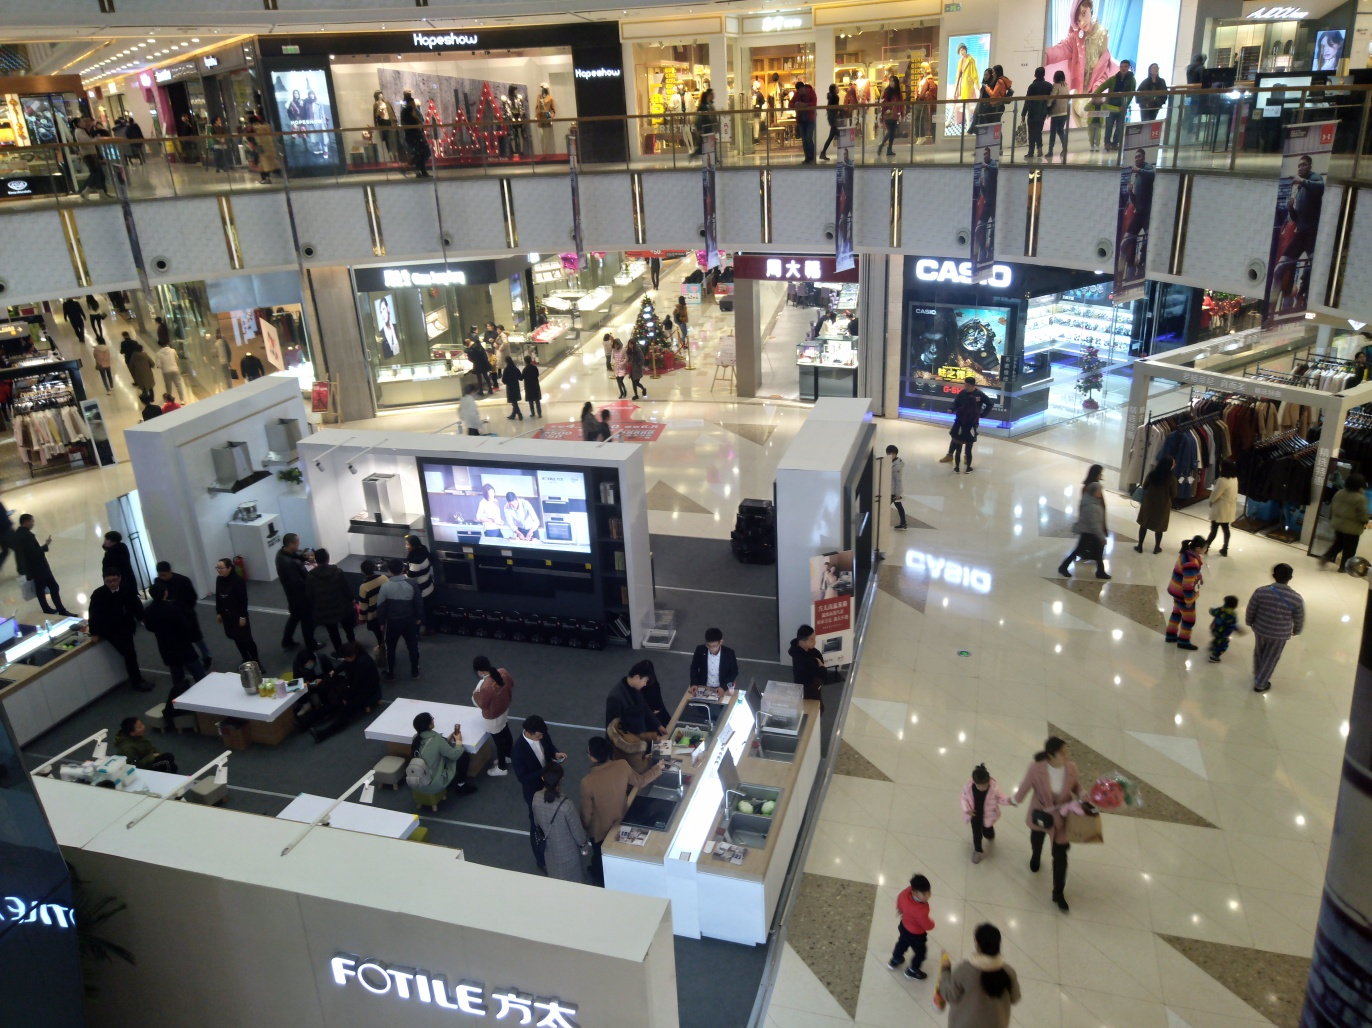Describe the architecture and design elements of the mall. The mall's architecture features a modern design with open, spacious areas allowing for free movement of shoppers. The balustrades are sleek and minimalistic, and there's a clear view of multiple floors which creates an airy feeling. Diverse lighting elements, from bright store signs to overhead ambient lighting, contribute to the mall's contemporary vibe. 